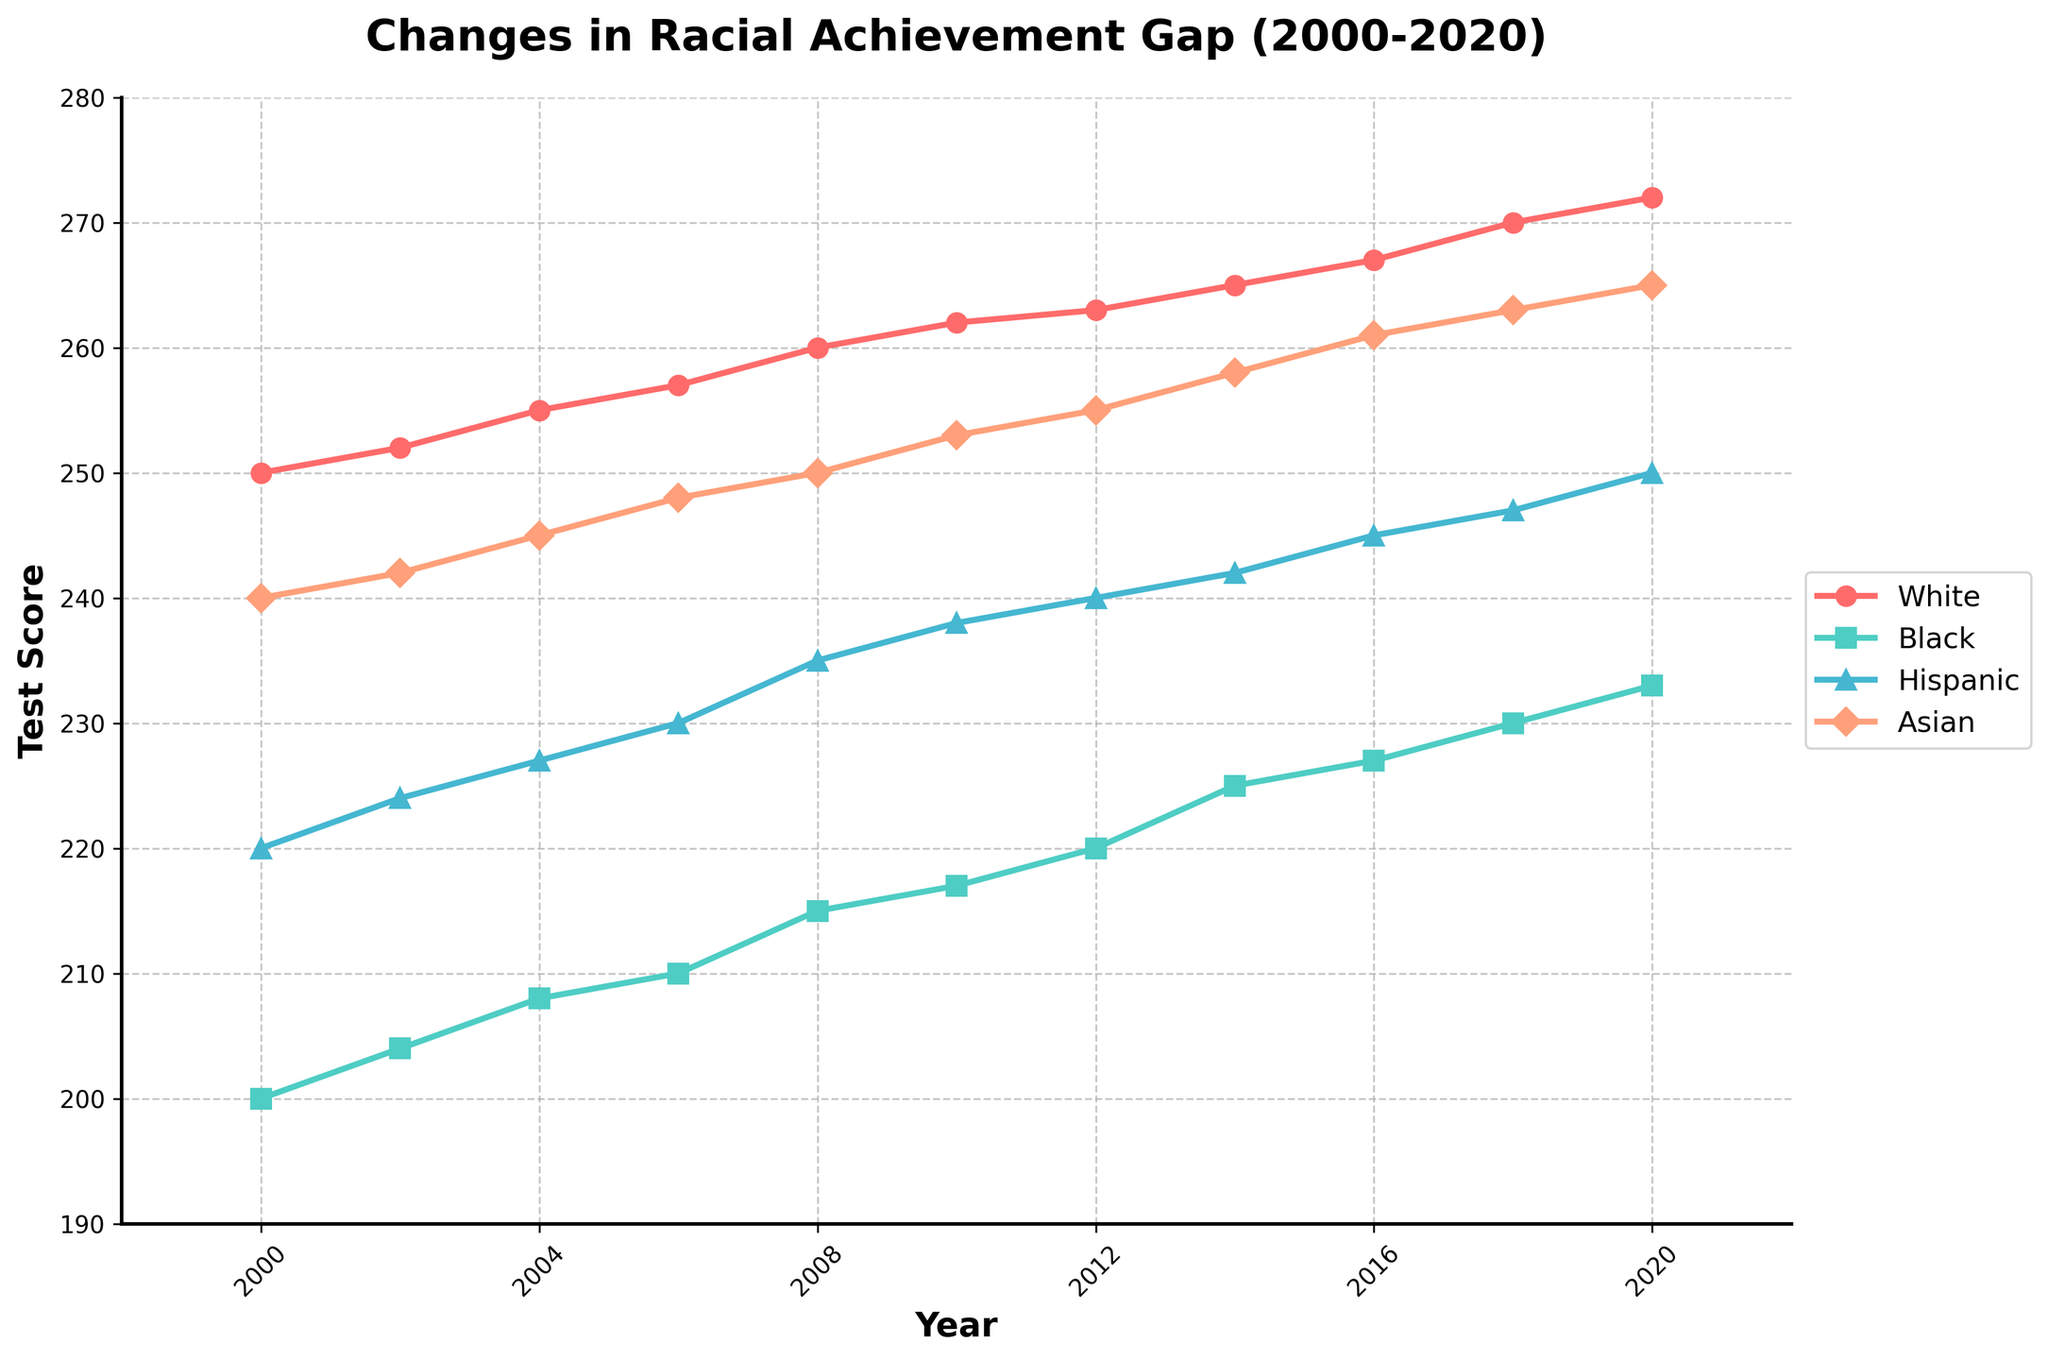How many different racial groups are represented in the plot? The plot shows four lines with different colors and markers representing four racial groups.
Answer: Four What is the title of the time series plot? The title is displayed at the top of the plot.
Answer: Changes in Racial Achievement Gap (2000-2020) Which racial group has the highest test score in 2020? To find the highest test score, you look at the last data point in 2020 and compare the scores of all racial groups.
Answer: White Between which years do all racial groups show a continuous increase in test scores? All data points for each racial group from 2000 to 2020 must be checked to ensure continuous growth.
Answer: 2000 to 2020 How much did the average test score of Hispanic students increase from 2000 to 2020? Subtract the Hispanic students' score in 2000 from their score in 2020 to find the total increase.
Answer: 30 points In which year did Black students' test score exceed 220? Check the scores for Black students across the years and identify when it first becomes greater than 220.
Answer: 2012 What is the difference in test scores between White and Black students in 2008? Subtract Black students' score from White students' score for the year 2008.
Answer: 45 points What trend can be observed for Asian students' test scores from 2000 to 2020? Examine the plotted line for Asian students and describe the general direction of the line over the years.
Answer: Increasing Which racial group showed the least improvement in test scores from 2000 to 2020? Calculate the difference in test scores from 2000 to 2020 for each group and compare the values to find the smallest improvement.
Answer: Black Between 2010 and 2014, which racial group's test scores increased the most? Subtract the 2010 scores from the 2014 scores for all racial groups and find the group with the highest increase.
Answer: Hispanic 